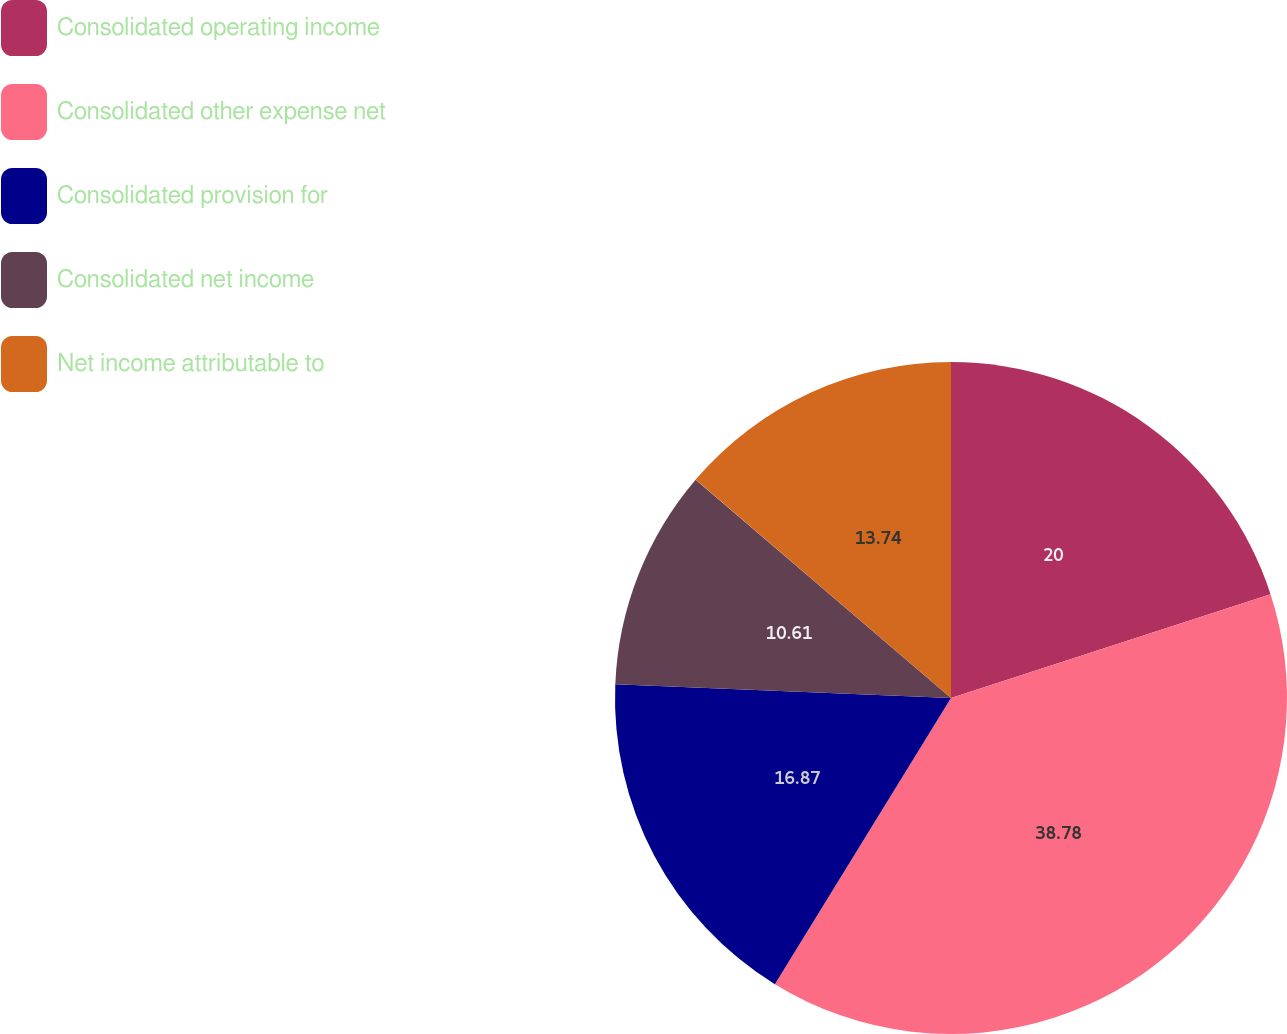<chart> <loc_0><loc_0><loc_500><loc_500><pie_chart><fcel>Consolidated operating income<fcel>Consolidated other expense net<fcel>Consolidated provision for<fcel>Consolidated net income<fcel>Net income attributable to<nl><fcel>20.0%<fcel>38.78%<fcel>16.87%<fcel>10.61%<fcel>13.74%<nl></chart> 